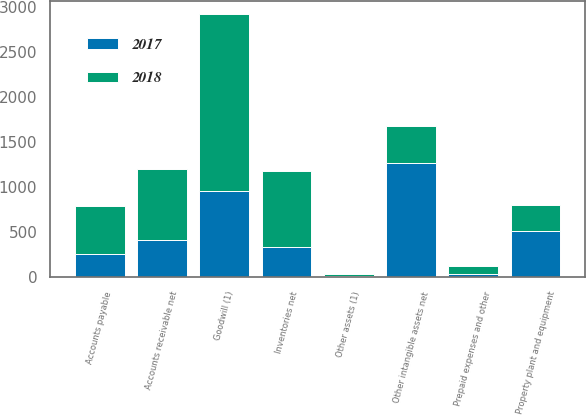Convert chart. <chart><loc_0><loc_0><loc_500><loc_500><stacked_bar_chart><ecel><fcel>Accounts receivable net<fcel>Inventories net<fcel>Prepaid expenses and other<fcel>Property plant and equipment<fcel>Goodwill (1)<fcel>Other intangible assets net<fcel>Other assets (1)<fcel>Accounts payable<nl><fcel>2017<fcel>411.7<fcel>338.7<fcel>40.4<fcel>515.9<fcel>954.4<fcel>1270.8<fcel>9.4<fcel>256.7<nl><fcel>2018<fcel>794.7<fcel>836.4<fcel>87.6<fcel>291.9<fcel>1966.3<fcel>411.7<fcel>29.4<fcel>534.8<nl></chart> 